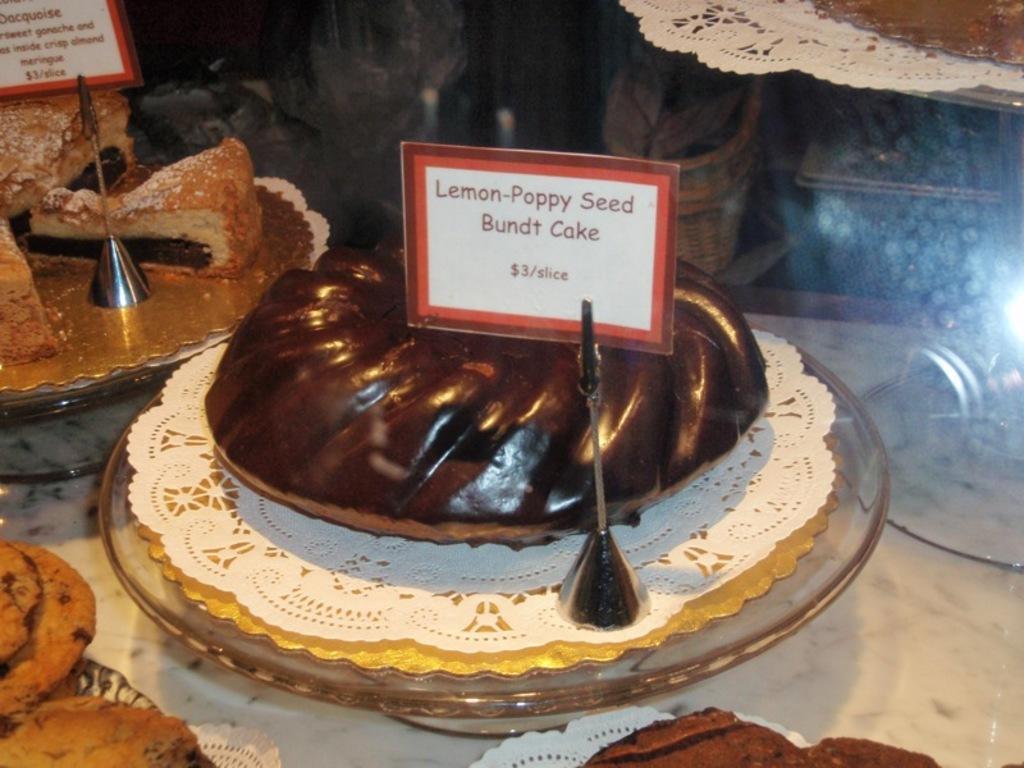Please provide a concise description of this image. In this image I can see few plates which consists of a cake, pastries and some other food items. Along with the food items there are two tags on which I can see the text. On the right side there is a glass object. These are placed on a white surface. The background is blurred. 